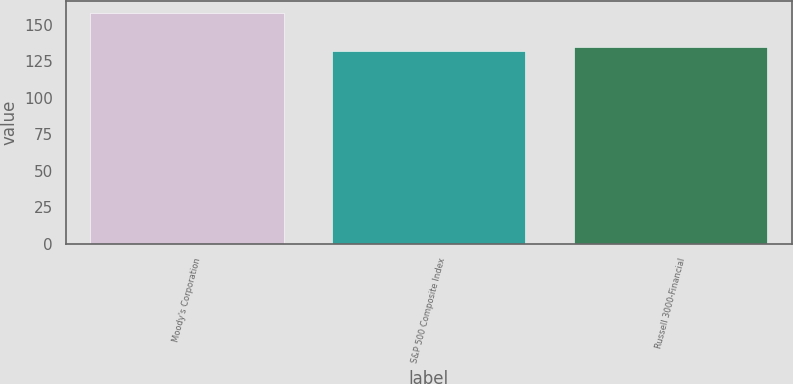Convert chart to OTSL. <chart><loc_0><loc_0><loc_500><loc_500><bar_chart><fcel>Moody's Corporation<fcel>S&P 500 Composite Index<fcel>Russell 3000-Financial<nl><fcel>158.22<fcel>132.39<fcel>134.97<nl></chart> 